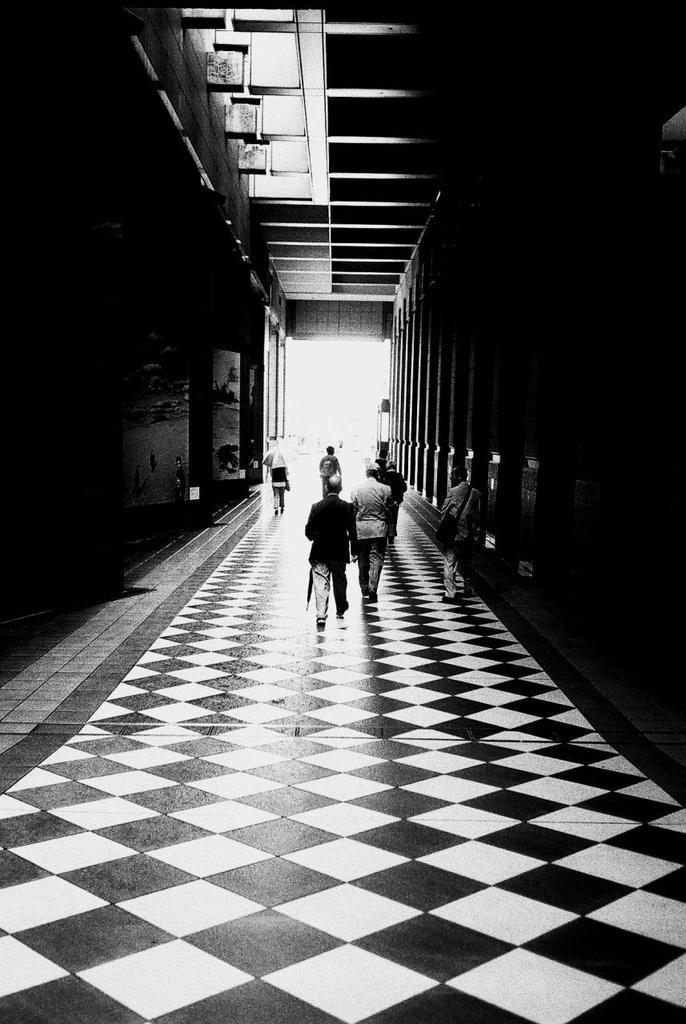Please provide a concise description of this image. This is a black and white image. In the middle of this image, there are persons walking on a floor. On both sides of this floor, there are blocks of a building. And the background is white in color. 